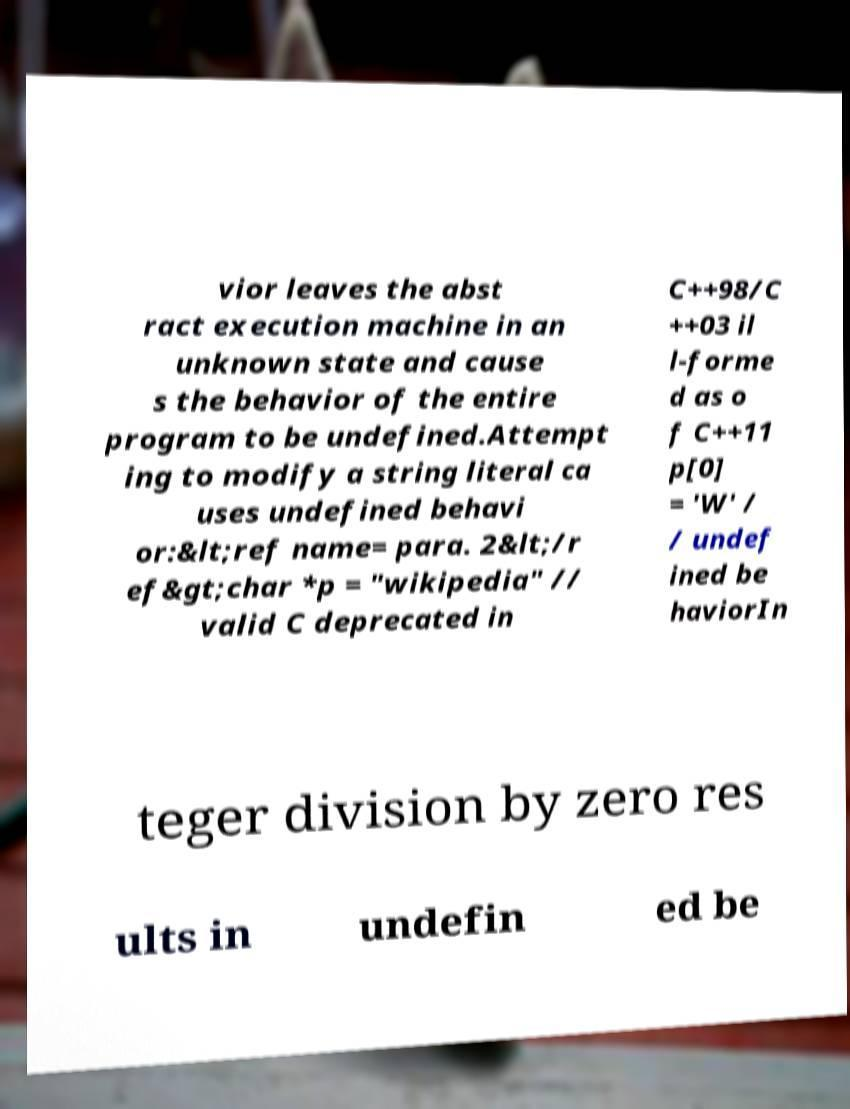Please read and relay the text visible in this image. What does it say? vior leaves the abst ract execution machine in an unknown state and cause s the behavior of the entire program to be undefined.Attempt ing to modify a string literal ca uses undefined behavi or:&lt;ref name= para. 2&lt;/r ef&gt;char *p = "wikipedia" // valid C deprecated in C++98/C ++03 il l-forme d as o f C++11 p[0] = 'W' / / undef ined be haviorIn teger division by zero res ults in undefin ed be 